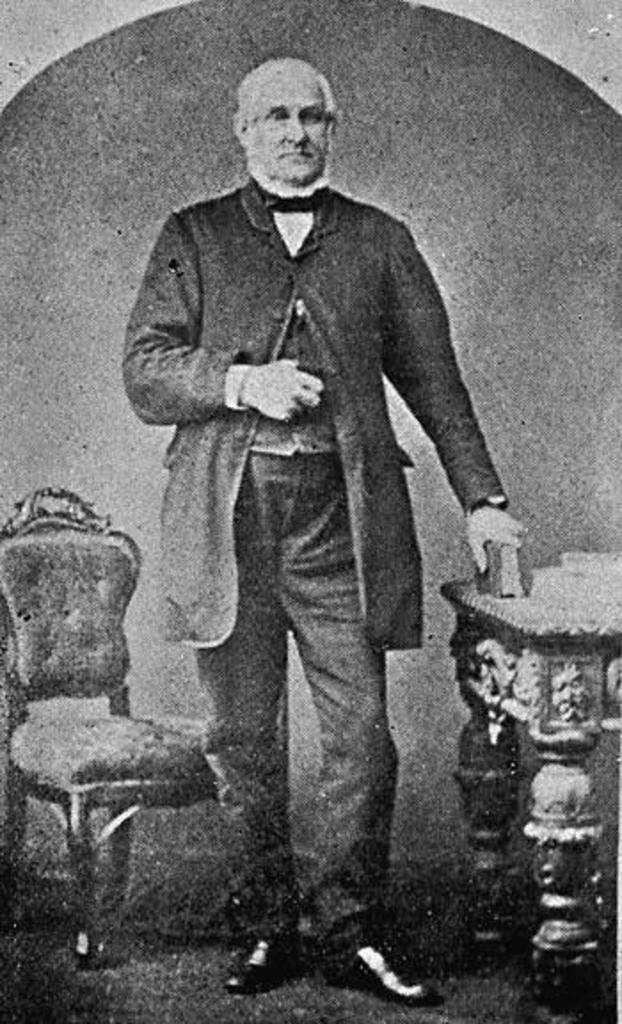What is the color scheme of the image? The image is black and white. What is the man in the image wearing? The man is wearing a suit, trousers, and shoes. What is the man holding in the image? The man is holding a book. What type of furniture is present in the image? There is a wooden table and a chair in the image. How many amusement parks can be seen in the image? There are no amusement parks present in the image. What is the amount of nighttime visible in the image? The image is black and white, and there is no reference to time of day, so it cannot be determined if nighttime is visible. 